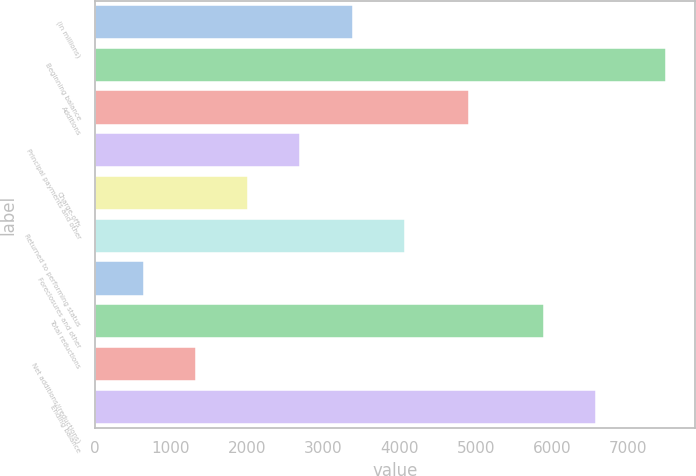<chart> <loc_0><loc_0><loc_500><loc_500><bar_chart><fcel>(in millions)<fcel>Beginning balance<fcel>Additions<fcel>Principal payments and other<fcel>Charge-offs<fcel>Returned to performing status<fcel>Foreclosures and other<fcel>Total reductions<fcel>Net additions/(reductions)<fcel>Ending balance<nl><fcel>3384.8<fcel>7496<fcel>4905<fcel>2699.6<fcel>2014.4<fcel>4070<fcel>644<fcel>5892<fcel>1329.2<fcel>6577.2<nl></chart> 